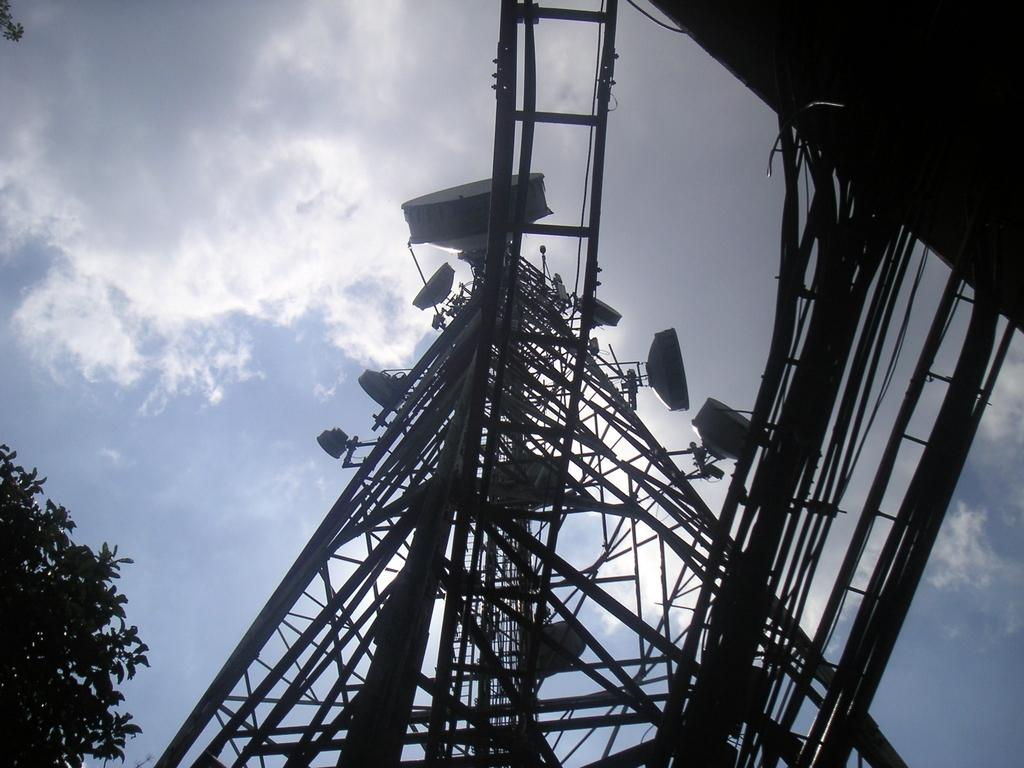What can be seen in the sky in the image? The sky is visible in the image, and there are clouds in the sky. What type of structure is present in the image? There is a tower in the image. What is attached to the tower? Wires and rods are attached to the tower. What else is present in the image? There is a tree and a ladder in the image. What type of wine is being served in the image? There is no wine present in the image. Does the existence of the tree in the image prove the existence of a spade? The presence of a tree in the image does not prove the existence of a spade, as there is no mention of a spade in the provided facts. 